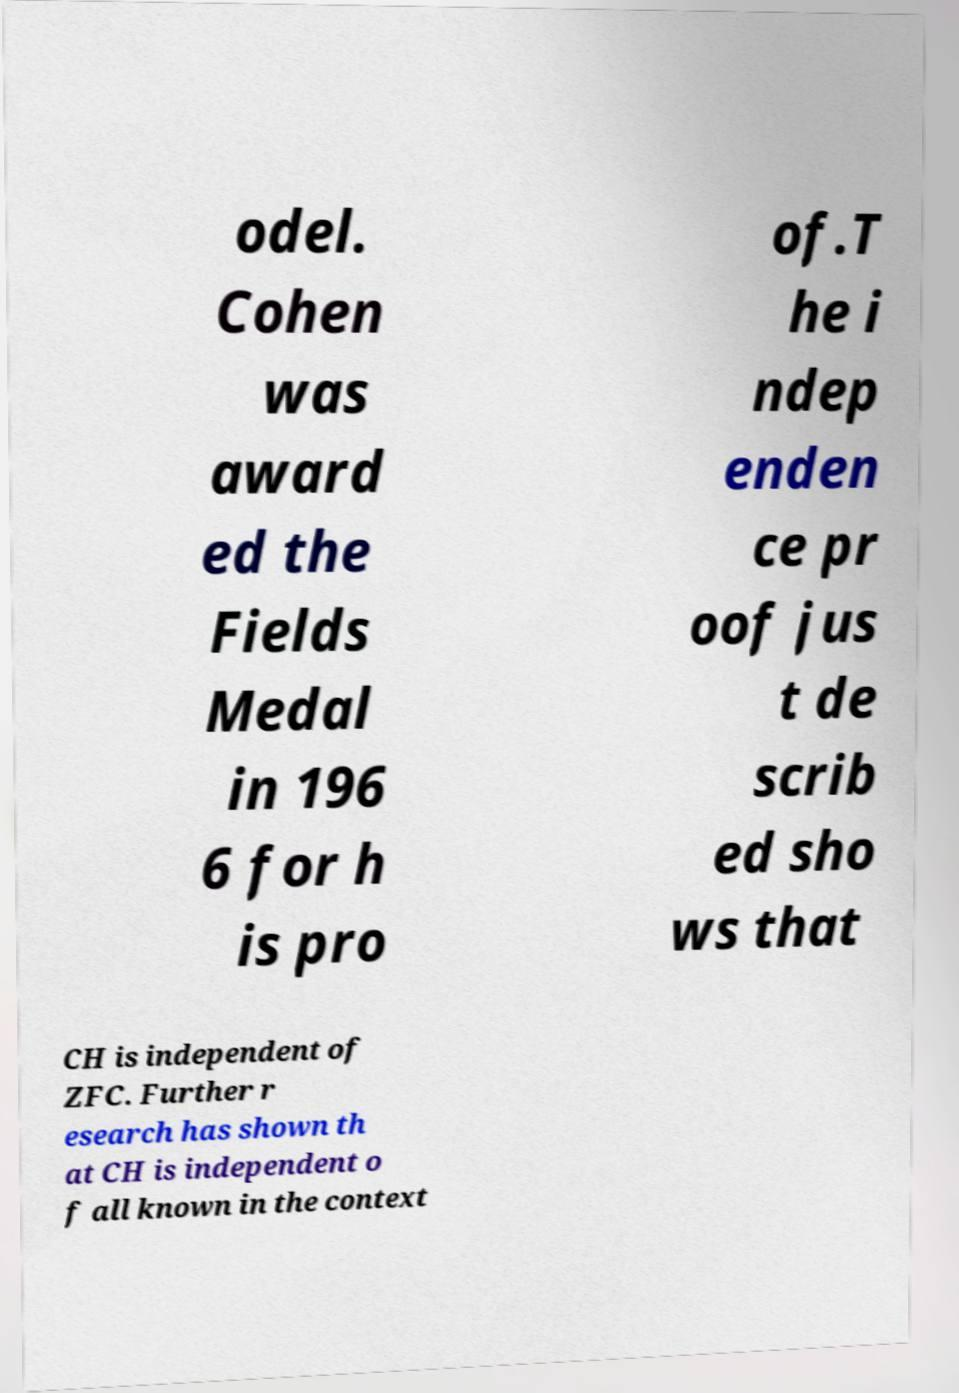Could you assist in decoding the text presented in this image and type it out clearly? odel. Cohen was award ed the Fields Medal in 196 6 for h is pro of.T he i ndep enden ce pr oof jus t de scrib ed sho ws that CH is independent of ZFC. Further r esearch has shown th at CH is independent o f all known in the context 